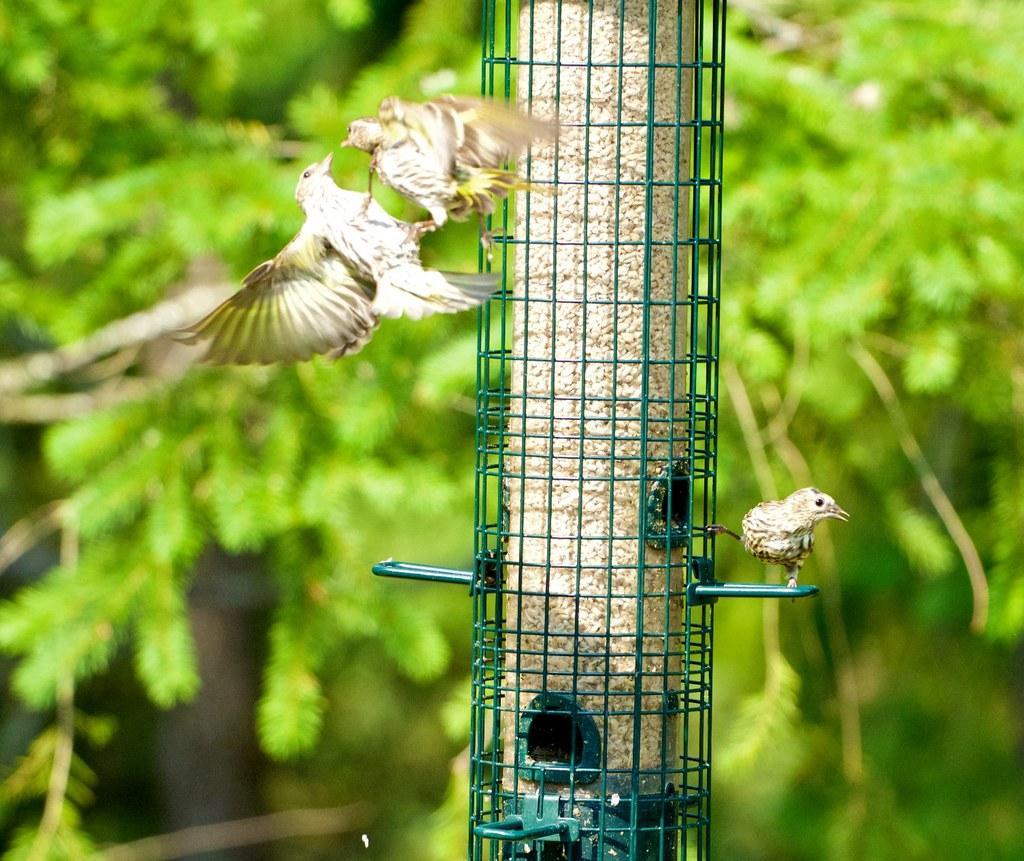In one or two sentences, can you explain what this image depicts? In the foreground of this image, there is a bird on the bird feeding station and other two birds are in the air. In the background, there is the greenery. 